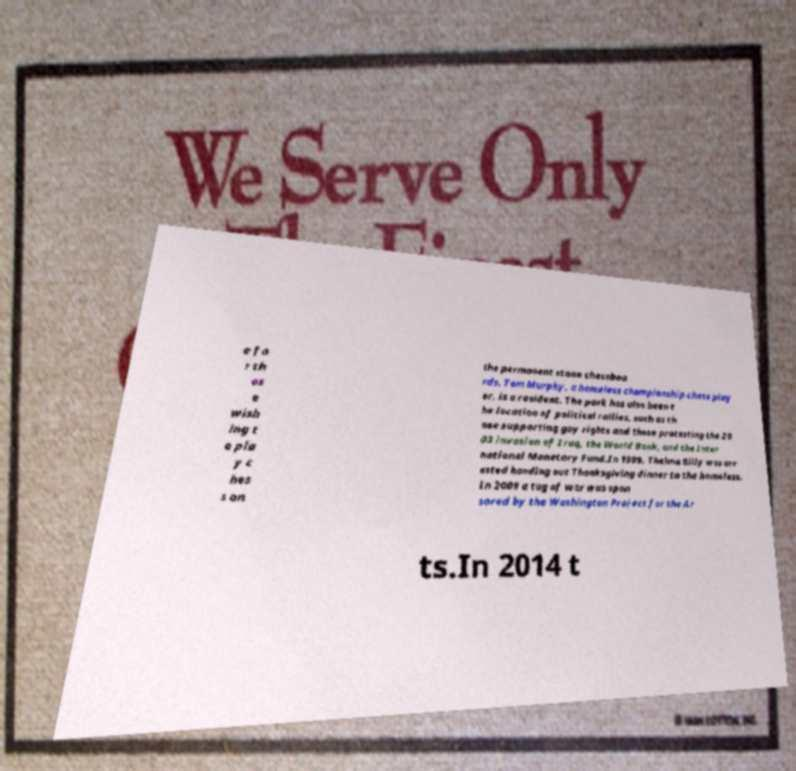There's text embedded in this image that I need extracted. Can you transcribe it verbatim? e fo r th os e wish ing t o pla y c hes s on the permanent stone chessboa rds. Tom Murphy, a homeless championship chess play er, is a resident. The park has also been t he location of political rallies, such as th ose supporting gay rights and those protesting the 20 03 invasion of Iraq, the World Bank, and the Inter national Monetary Fund.In 1999, Thelma Billy was arr ested handing out Thanksgiving dinner to the homeless. In 2009 a tug of war was spon sored by the Washington Project for the Ar ts.In 2014 t 